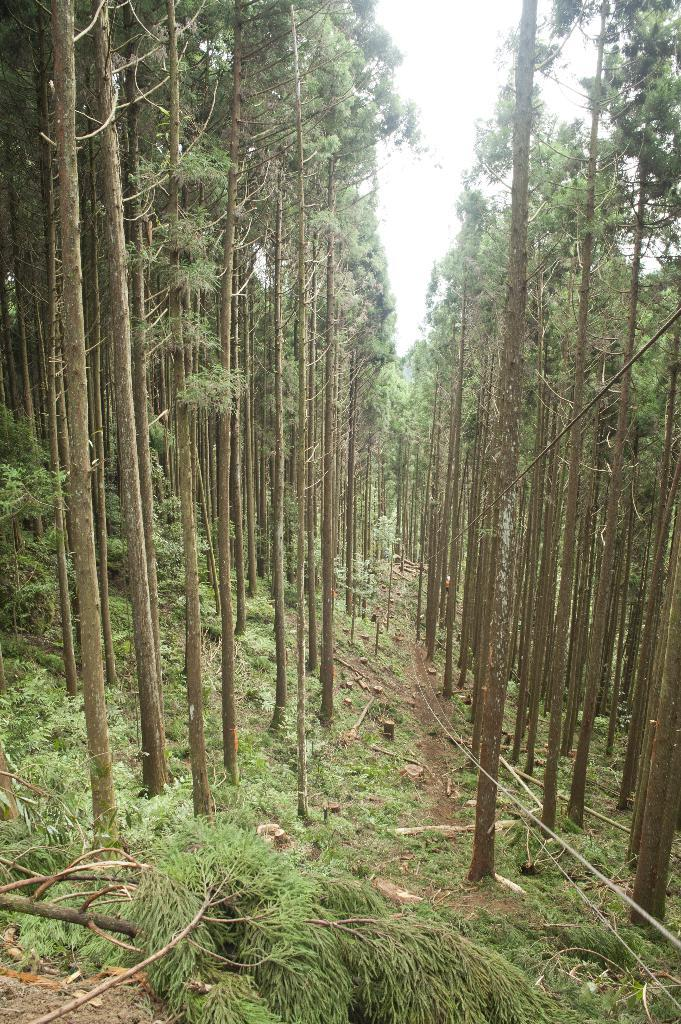What type of vegetation can be seen in the image? There are trees and grass in the image. What else can be found on the ground in the image? Leaves are present in the image. What is visible in the sky in the image? The sky is white in the image. How many laborers are working in the image? There are no laborers present in the image. What type of glass object can be seen in the image? There is no glass object present in the image. 